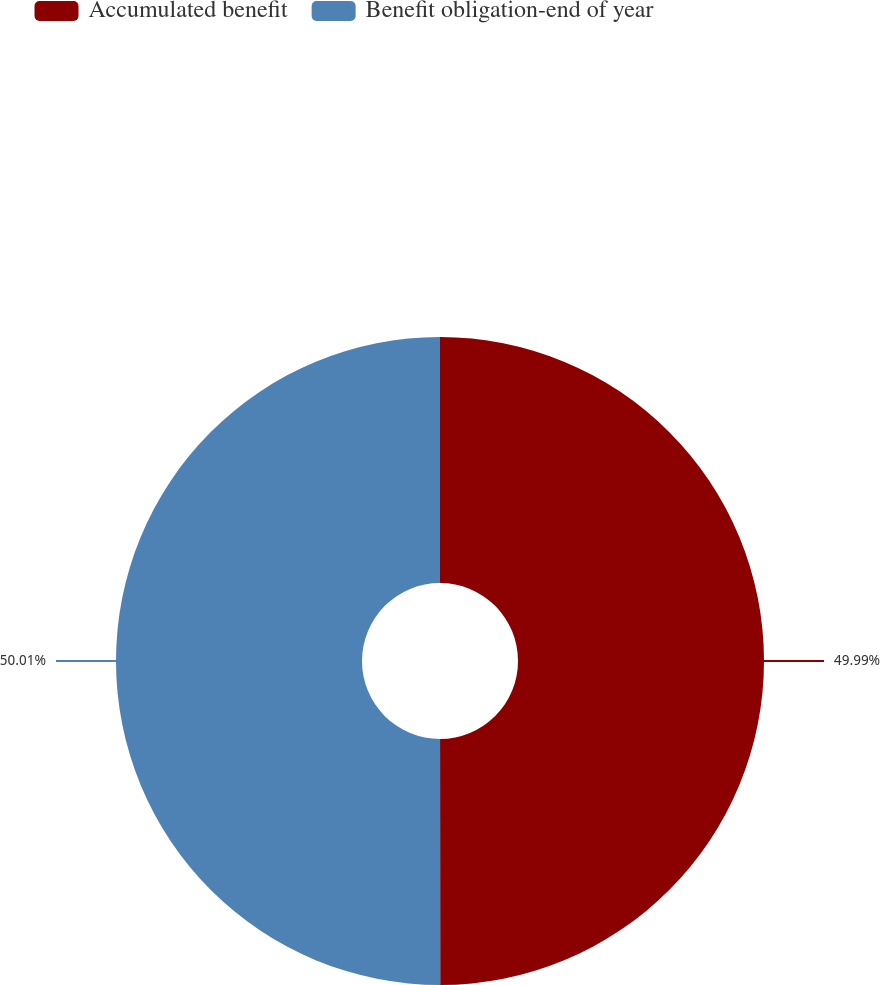<chart> <loc_0><loc_0><loc_500><loc_500><pie_chart><fcel>Accumulated benefit<fcel>Benefit obligation-end of year<nl><fcel>49.99%<fcel>50.01%<nl></chart> 